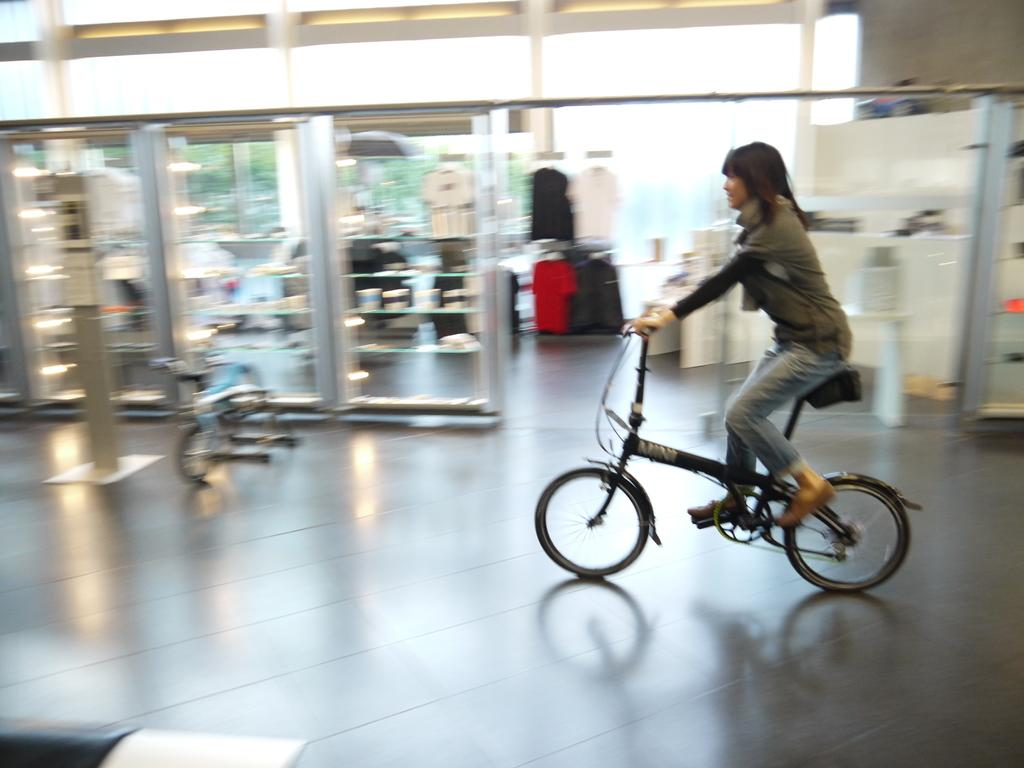Who is the main subject in the image? There is a woman in the image. What is the woman doing in the image? The woman is riding a bicycle. What can be seen in the background of the image? There are shelves in the background of the image, and t-shirts and shirts are visible on them. What is the structure above the woman in the image? There is a roof in the image. What type of fact can be seen on the side of the woman's neck in the image? There is no fact visible on the side of the woman's neck in the image. 